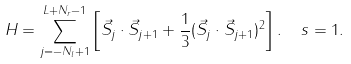<formula> <loc_0><loc_0><loc_500><loc_500>H = \sum _ { j = - N _ { l } + 1 } ^ { L + N _ { r } - 1 } \left [ { \vec { S } } _ { j } \cdot { \vec { S } } _ { j + 1 } + \frac { 1 } { 3 } ( { \vec { S } } _ { j } \cdot { \vec { S } } _ { j + 1 } ) ^ { 2 } \right ] . \ \ s = 1 .</formula> 